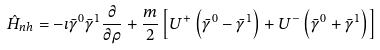<formula> <loc_0><loc_0><loc_500><loc_500>\hat { H } _ { n h } = - \imath \bar { \gamma } ^ { 0 } \bar { \gamma } ^ { 1 } \frac { \partial } { \partial \rho } + \frac { m } { 2 } \left [ U ^ { + } \left ( \bar { \gamma } ^ { 0 } - \bar { \gamma } ^ { 1 } \right ) + U ^ { - } \left ( \bar { \gamma } ^ { 0 } + \bar { \gamma } ^ { 1 } \right ) \right ]</formula> 